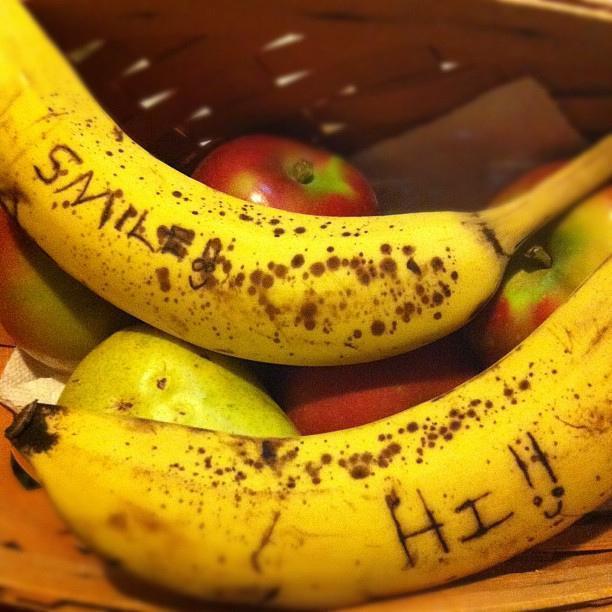What is on the fruit?
Indicate the correct response and explain using: 'Answer: answer
Rationale: rationale.'
Options: Ants, flies, writing, mold. Answer: writing.
Rationale: You can see the letters carved into the banana. the surface of the banana is soft and can be carved. What animal do the spots on the banana most resemble?
Pick the correct solution from the four options below to address the question.
Options: Bear, hippo, giraffe, lion. Giraffe. 